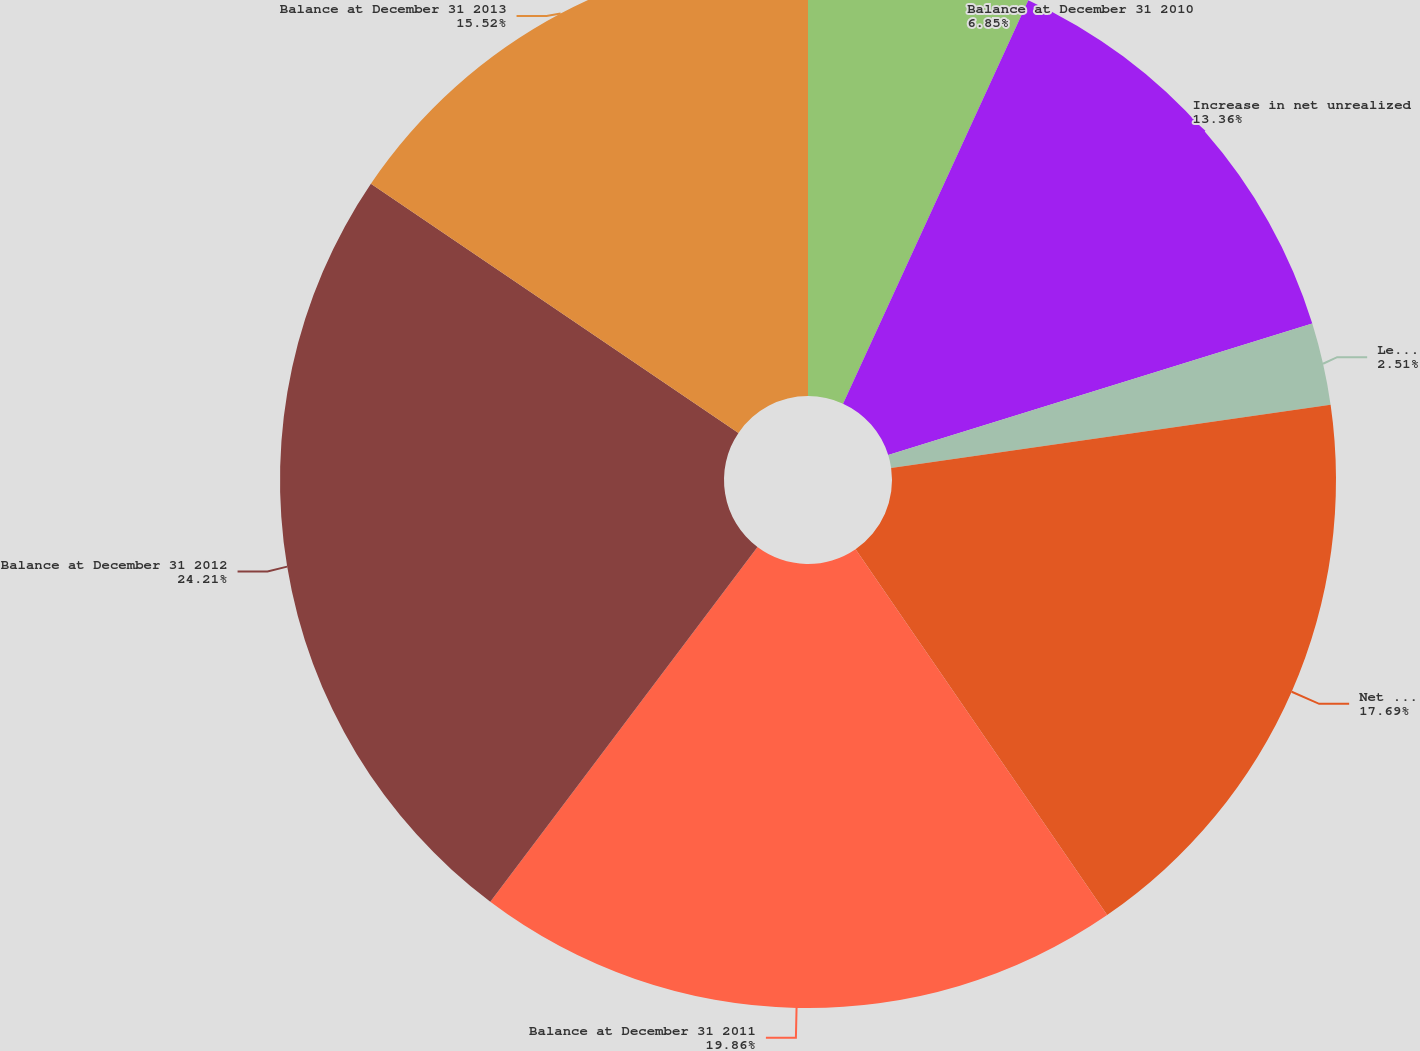Convert chart to OTSL. <chart><loc_0><loc_0><loc_500><loc_500><pie_chart><fcel>Balance at December 31 2010<fcel>Increase in net unrealized<fcel>Less Net gains (losses)<fcel>Net unrealized gains (losses)<fcel>Balance at December 31 2011<fcel>Balance at December 31 2012<fcel>Balance at December 31 2013<nl><fcel>6.85%<fcel>13.36%<fcel>2.51%<fcel>17.69%<fcel>19.86%<fcel>24.2%<fcel>15.52%<nl></chart> 